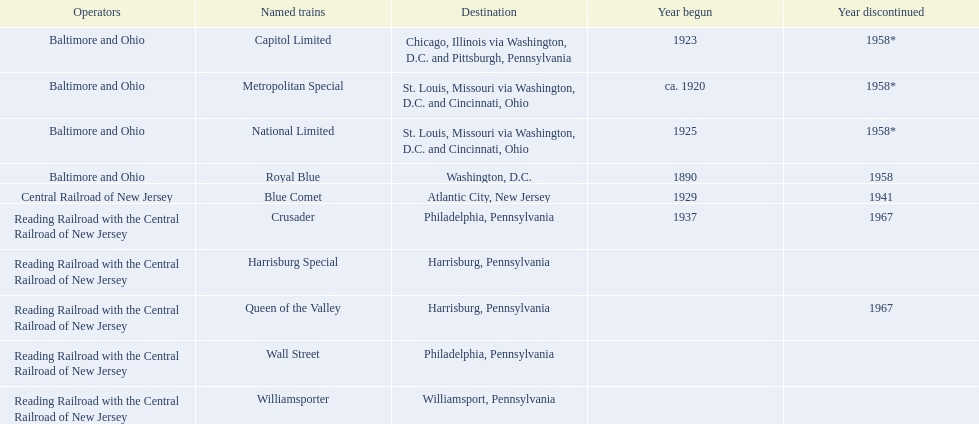Which operators are the reading railroad with the central railroad of new jersey? Reading Railroad with the Central Railroad of New Jersey, Reading Railroad with the Central Railroad of New Jersey, Reading Railroad with the Central Railroad of New Jersey, Reading Railroad with the Central Railroad of New Jersey, Reading Railroad with the Central Railroad of New Jersey. Which destinations are philadelphia, pennsylvania? Philadelphia, Pennsylvania, Philadelphia, Pennsylvania. What on began in 1937? 1937. What is the named train? Crusader. 